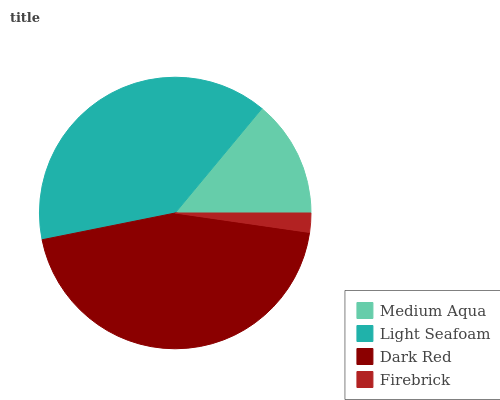Is Firebrick the minimum?
Answer yes or no. Yes. Is Dark Red the maximum?
Answer yes or no. Yes. Is Light Seafoam the minimum?
Answer yes or no. No. Is Light Seafoam the maximum?
Answer yes or no. No. Is Light Seafoam greater than Medium Aqua?
Answer yes or no. Yes. Is Medium Aqua less than Light Seafoam?
Answer yes or no. Yes. Is Medium Aqua greater than Light Seafoam?
Answer yes or no. No. Is Light Seafoam less than Medium Aqua?
Answer yes or no. No. Is Light Seafoam the high median?
Answer yes or no. Yes. Is Medium Aqua the low median?
Answer yes or no. Yes. Is Medium Aqua the high median?
Answer yes or no. No. Is Light Seafoam the low median?
Answer yes or no. No. 